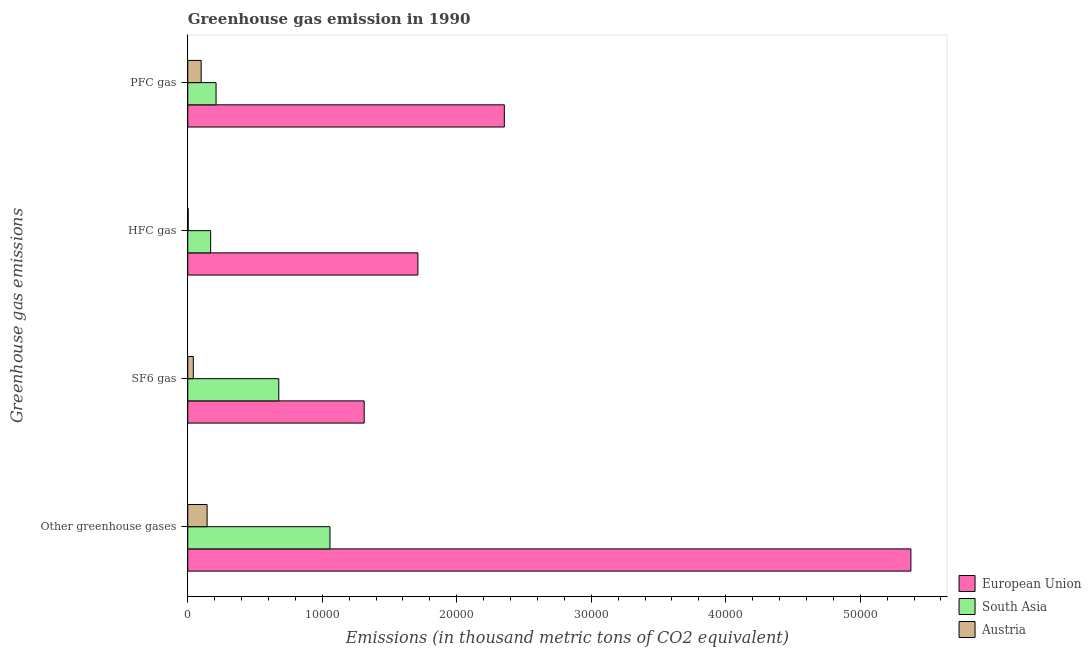Are the number of bars per tick equal to the number of legend labels?
Ensure brevity in your answer.  Yes. Are the number of bars on each tick of the Y-axis equal?
Provide a succinct answer. Yes. How many bars are there on the 2nd tick from the bottom?
Give a very brief answer. 3. What is the label of the 4th group of bars from the top?
Keep it short and to the point. Other greenhouse gases. What is the emission of pfc gas in European Union?
Give a very brief answer. 2.35e+04. Across all countries, what is the maximum emission of pfc gas?
Make the answer very short. 2.35e+04. Across all countries, what is the minimum emission of sf6 gas?
Your answer should be compact. 411.2. In which country was the emission of sf6 gas maximum?
Offer a terse response. European Union. In which country was the emission of sf6 gas minimum?
Offer a terse response. Austria. What is the total emission of pfc gas in the graph?
Ensure brevity in your answer.  2.66e+04. What is the difference between the emission of sf6 gas in Austria and that in South Asia?
Offer a very short reply. -6355.3. What is the difference between the emission of sf6 gas in South Asia and the emission of hfc gas in Austria?
Keep it short and to the point. 6735.6. What is the average emission of pfc gas per country?
Offer a very short reply. 8878.73. What is the difference between the emission of sf6 gas and emission of hfc gas in South Asia?
Your response must be concise. 5064.4. What is the ratio of the emission of hfc gas in Austria to that in South Asia?
Your answer should be very brief. 0.02. Is the emission of pfc gas in South Asia less than that in Austria?
Make the answer very short. No. What is the difference between the highest and the second highest emission of greenhouse gases?
Provide a succinct answer. 4.32e+04. What is the difference between the highest and the lowest emission of sf6 gas?
Ensure brevity in your answer.  1.27e+04. Is it the case that in every country, the sum of the emission of hfc gas and emission of pfc gas is greater than the sum of emission of sf6 gas and emission of greenhouse gases?
Provide a succinct answer. No. What does the 1st bar from the top in SF6 gas represents?
Your response must be concise. Austria. What does the 2nd bar from the bottom in HFC gas represents?
Your response must be concise. South Asia. Is it the case that in every country, the sum of the emission of greenhouse gases and emission of sf6 gas is greater than the emission of hfc gas?
Your response must be concise. Yes. Are all the bars in the graph horizontal?
Make the answer very short. Yes. What is the difference between two consecutive major ticks on the X-axis?
Provide a succinct answer. 10000. Does the graph contain any zero values?
Your answer should be very brief. No. Does the graph contain grids?
Give a very brief answer. No. How many legend labels are there?
Offer a very short reply. 3. What is the title of the graph?
Provide a succinct answer. Greenhouse gas emission in 1990. Does "Vanuatu" appear as one of the legend labels in the graph?
Keep it short and to the point. No. What is the label or title of the X-axis?
Your response must be concise. Emissions (in thousand metric tons of CO2 equivalent). What is the label or title of the Y-axis?
Your response must be concise. Greenhouse gas emissions. What is the Emissions (in thousand metric tons of CO2 equivalent) in European Union in Other greenhouse gases?
Your answer should be very brief. 5.38e+04. What is the Emissions (in thousand metric tons of CO2 equivalent) of South Asia in Other greenhouse gases?
Offer a terse response. 1.06e+04. What is the Emissions (in thousand metric tons of CO2 equivalent) in Austria in Other greenhouse gases?
Ensure brevity in your answer.  1437.8. What is the Emissions (in thousand metric tons of CO2 equivalent) in European Union in SF6 gas?
Your response must be concise. 1.31e+04. What is the Emissions (in thousand metric tons of CO2 equivalent) of South Asia in SF6 gas?
Your response must be concise. 6766.5. What is the Emissions (in thousand metric tons of CO2 equivalent) of Austria in SF6 gas?
Offer a very short reply. 411.2. What is the Emissions (in thousand metric tons of CO2 equivalent) in European Union in HFC gas?
Offer a very short reply. 1.71e+04. What is the Emissions (in thousand metric tons of CO2 equivalent) in South Asia in HFC gas?
Your response must be concise. 1702.1. What is the Emissions (in thousand metric tons of CO2 equivalent) in Austria in HFC gas?
Your response must be concise. 30.9. What is the Emissions (in thousand metric tons of CO2 equivalent) in European Union in PFC gas?
Make the answer very short. 2.35e+04. What is the Emissions (in thousand metric tons of CO2 equivalent) in South Asia in PFC gas?
Your response must be concise. 2104. What is the Emissions (in thousand metric tons of CO2 equivalent) of Austria in PFC gas?
Your answer should be compact. 995.7. Across all Greenhouse gas emissions, what is the maximum Emissions (in thousand metric tons of CO2 equivalent) in European Union?
Provide a short and direct response. 5.38e+04. Across all Greenhouse gas emissions, what is the maximum Emissions (in thousand metric tons of CO2 equivalent) of South Asia?
Provide a succinct answer. 1.06e+04. Across all Greenhouse gas emissions, what is the maximum Emissions (in thousand metric tons of CO2 equivalent) of Austria?
Offer a very short reply. 1437.8. Across all Greenhouse gas emissions, what is the minimum Emissions (in thousand metric tons of CO2 equivalent) in European Union?
Your answer should be very brief. 1.31e+04. Across all Greenhouse gas emissions, what is the minimum Emissions (in thousand metric tons of CO2 equivalent) of South Asia?
Give a very brief answer. 1702.1. Across all Greenhouse gas emissions, what is the minimum Emissions (in thousand metric tons of CO2 equivalent) in Austria?
Your answer should be very brief. 30.9. What is the total Emissions (in thousand metric tons of CO2 equivalent) in European Union in the graph?
Keep it short and to the point. 1.08e+05. What is the total Emissions (in thousand metric tons of CO2 equivalent) in South Asia in the graph?
Make the answer very short. 2.11e+04. What is the total Emissions (in thousand metric tons of CO2 equivalent) of Austria in the graph?
Offer a very short reply. 2875.6. What is the difference between the Emissions (in thousand metric tons of CO2 equivalent) of European Union in Other greenhouse gases and that in SF6 gas?
Keep it short and to the point. 4.06e+04. What is the difference between the Emissions (in thousand metric tons of CO2 equivalent) of South Asia in Other greenhouse gases and that in SF6 gas?
Offer a very short reply. 3806.1. What is the difference between the Emissions (in thousand metric tons of CO2 equivalent) of Austria in Other greenhouse gases and that in SF6 gas?
Ensure brevity in your answer.  1026.6. What is the difference between the Emissions (in thousand metric tons of CO2 equivalent) of European Union in Other greenhouse gases and that in HFC gas?
Keep it short and to the point. 3.67e+04. What is the difference between the Emissions (in thousand metric tons of CO2 equivalent) of South Asia in Other greenhouse gases and that in HFC gas?
Provide a short and direct response. 8870.5. What is the difference between the Emissions (in thousand metric tons of CO2 equivalent) of Austria in Other greenhouse gases and that in HFC gas?
Ensure brevity in your answer.  1406.9. What is the difference between the Emissions (in thousand metric tons of CO2 equivalent) of European Union in Other greenhouse gases and that in PFC gas?
Make the answer very short. 3.02e+04. What is the difference between the Emissions (in thousand metric tons of CO2 equivalent) in South Asia in Other greenhouse gases and that in PFC gas?
Give a very brief answer. 8468.6. What is the difference between the Emissions (in thousand metric tons of CO2 equivalent) of Austria in Other greenhouse gases and that in PFC gas?
Keep it short and to the point. 442.1. What is the difference between the Emissions (in thousand metric tons of CO2 equivalent) of European Union in SF6 gas and that in HFC gas?
Your response must be concise. -3993.7. What is the difference between the Emissions (in thousand metric tons of CO2 equivalent) of South Asia in SF6 gas and that in HFC gas?
Your answer should be compact. 5064.4. What is the difference between the Emissions (in thousand metric tons of CO2 equivalent) in Austria in SF6 gas and that in HFC gas?
Your response must be concise. 380.3. What is the difference between the Emissions (in thousand metric tons of CO2 equivalent) of European Union in SF6 gas and that in PFC gas?
Provide a short and direct response. -1.04e+04. What is the difference between the Emissions (in thousand metric tons of CO2 equivalent) of South Asia in SF6 gas and that in PFC gas?
Provide a short and direct response. 4662.5. What is the difference between the Emissions (in thousand metric tons of CO2 equivalent) in Austria in SF6 gas and that in PFC gas?
Ensure brevity in your answer.  -584.5. What is the difference between the Emissions (in thousand metric tons of CO2 equivalent) of European Union in HFC gas and that in PFC gas?
Your response must be concise. -6426.3. What is the difference between the Emissions (in thousand metric tons of CO2 equivalent) in South Asia in HFC gas and that in PFC gas?
Offer a very short reply. -401.9. What is the difference between the Emissions (in thousand metric tons of CO2 equivalent) in Austria in HFC gas and that in PFC gas?
Your answer should be compact. -964.8. What is the difference between the Emissions (in thousand metric tons of CO2 equivalent) in European Union in Other greenhouse gases and the Emissions (in thousand metric tons of CO2 equivalent) in South Asia in SF6 gas?
Keep it short and to the point. 4.70e+04. What is the difference between the Emissions (in thousand metric tons of CO2 equivalent) of European Union in Other greenhouse gases and the Emissions (in thousand metric tons of CO2 equivalent) of Austria in SF6 gas?
Ensure brevity in your answer.  5.34e+04. What is the difference between the Emissions (in thousand metric tons of CO2 equivalent) in South Asia in Other greenhouse gases and the Emissions (in thousand metric tons of CO2 equivalent) in Austria in SF6 gas?
Keep it short and to the point. 1.02e+04. What is the difference between the Emissions (in thousand metric tons of CO2 equivalent) of European Union in Other greenhouse gases and the Emissions (in thousand metric tons of CO2 equivalent) of South Asia in HFC gas?
Make the answer very short. 5.21e+04. What is the difference between the Emissions (in thousand metric tons of CO2 equivalent) of European Union in Other greenhouse gases and the Emissions (in thousand metric tons of CO2 equivalent) of Austria in HFC gas?
Your answer should be compact. 5.37e+04. What is the difference between the Emissions (in thousand metric tons of CO2 equivalent) of South Asia in Other greenhouse gases and the Emissions (in thousand metric tons of CO2 equivalent) of Austria in HFC gas?
Ensure brevity in your answer.  1.05e+04. What is the difference between the Emissions (in thousand metric tons of CO2 equivalent) of European Union in Other greenhouse gases and the Emissions (in thousand metric tons of CO2 equivalent) of South Asia in PFC gas?
Offer a terse response. 5.17e+04. What is the difference between the Emissions (in thousand metric tons of CO2 equivalent) in European Union in Other greenhouse gases and the Emissions (in thousand metric tons of CO2 equivalent) in Austria in PFC gas?
Give a very brief answer. 5.28e+04. What is the difference between the Emissions (in thousand metric tons of CO2 equivalent) in South Asia in Other greenhouse gases and the Emissions (in thousand metric tons of CO2 equivalent) in Austria in PFC gas?
Provide a succinct answer. 9576.9. What is the difference between the Emissions (in thousand metric tons of CO2 equivalent) in European Union in SF6 gas and the Emissions (in thousand metric tons of CO2 equivalent) in South Asia in HFC gas?
Give a very brief answer. 1.14e+04. What is the difference between the Emissions (in thousand metric tons of CO2 equivalent) in European Union in SF6 gas and the Emissions (in thousand metric tons of CO2 equivalent) in Austria in HFC gas?
Make the answer very short. 1.31e+04. What is the difference between the Emissions (in thousand metric tons of CO2 equivalent) in South Asia in SF6 gas and the Emissions (in thousand metric tons of CO2 equivalent) in Austria in HFC gas?
Provide a short and direct response. 6735.6. What is the difference between the Emissions (in thousand metric tons of CO2 equivalent) in European Union in SF6 gas and the Emissions (in thousand metric tons of CO2 equivalent) in South Asia in PFC gas?
Your response must be concise. 1.10e+04. What is the difference between the Emissions (in thousand metric tons of CO2 equivalent) of European Union in SF6 gas and the Emissions (in thousand metric tons of CO2 equivalent) of Austria in PFC gas?
Provide a short and direct response. 1.21e+04. What is the difference between the Emissions (in thousand metric tons of CO2 equivalent) in South Asia in SF6 gas and the Emissions (in thousand metric tons of CO2 equivalent) in Austria in PFC gas?
Provide a short and direct response. 5770.8. What is the difference between the Emissions (in thousand metric tons of CO2 equivalent) of European Union in HFC gas and the Emissions (in thousand metric tons of CO2 equivalent) of South Asia in PFC gas?
Offer a very short reply. 1.50e+04. What is the difference between the Emissions (in thousand metric tons of CO2 equivalent) of European Union in HFC gas and the Emissions (in thousand metric tons of CO2 equivalent) of Austria in PFC gas?
Make the answer very short. 1.61e+04. What is the difference between the Emissions (in thousand metric tons of CO2 equivalent) of South Asia in HFC gas and the Emissions (in thousand metric tons of CO2 equivalent) of Austria in PFC gas?
Ensure brevity in your answer.  706.4. What is the average Emissions (in thousand metric tons of CO2 equivalent) of European Union per Greenhouse gas emissions?
Give a very brief answer. 2.69e+04. What is the average Emissions (in thousand metric tons of CO2 equivalent) of South Asia per Greenhouse gas emissions?
Provide a short and direct response. 5286.3. What is the average Emissions (in thousand metric tons of CO2 equivalent) in Austria per Greenhouse gas emissions?
Offer a terse response. 718.9. What is the difference between the Emissions (in thousand metric tons of CO2 equivalent) of European Union and Emissions (in thousand metric tons of CO2 equivalent) of South Asia in Other greenhouse gases?
Provide a succinct answer. 4.32e+04. What is the difference between the Emissions (in thousand metric tons of CO2 equivalent) in European Union and Emissions (in thousand metric tons of CO2 equivalent) in Austria in Other greenhouse gases?
Make the answer very short. 5.23e+04. What is the difference between the Emissions (in thousand metric tons of CO2 equivalent) in South Asia and Emissions (in thousand metric tons of CO2 equivalent) in Austria in Other greenhouse gases?
Provide a succinct answer. 9134.8. What is the difference between the Emissions (in thousand metric tons of CO2 equivalent) in European Union and Emissions (in thousand metric tons of CO2 equivalent) in South Asia in SF6 gas?
Make the answer very short. 6350. What is the difference between the Emissions (in thousand metric tons of CO2 equivalent) of European Union and Emissions (in thousand metric tons of CO2 equivalent) of Austria in SF6 gas?
Your response must be concise. 1.27e+04. What is the difference between the Emissions (in thousand metric tons of CO2 equivalent) in South Asia and Emissions (in thousand metric tons of CO2 equivalent) in Austria in SF6 gas?
Provide a short and direct response. 6355.3. What is the difference between the Emissions (in thousand metric tons of CO2 equivalent) in European Union and Emissions (in thousand metric tons of CO2 equivalent) in South Asia in HFC gas?
Provide a succinct answer. 1.54e+04. What is the difference between the Emissions (in thousand metric tons of CO2 equivalent) in European Union and Emissions (in thousand metric tons of CO2 equivalent) in Austria in HFC gas?
Keep it short and to the point. 1.71e+04. What is the difference between the Emissions (in thousand metric tons of CO2 equivalent) of South Asia and Emissions (in thousand metric tons of CO2 equivalent) of Austria in HFC gas?
Your response must be concise. 1671.2. What is the difference between the Emissions (in thousand metric tons of CO2 equivalent) of European Union and Emissions (in thousand metric tons of CO2 equivalent) of South Asia in PFC gas?
Ensure brevity in your answer.  2.14e+04. What is the difference between the Emissions (in thousand metric tons of CO2 equivalent) of European Union and Emissions (in thousand metric tons of CO2 equivalent) of Austria in PFC gas?
Keep it short and to the point. 2.25e+04. What is the difference between the Emissions (in thousand metric tons of CO2 equivalent) of South Asia and Emissions (in thousand metric tons of CO2 equivalent) of Austria in PFC gas?
Keep it short and to the point. 1108.3. What is the ratio of the Emissions (in thousand metric tons of CO2 equivalent) of European Union in Other greenhouse gases to that in SF6 gas?
Provide a short and direct response. 4.1. What is the ratio of the Emissions (in thousand metric tons of CO2 equivalent) in South Asia in Other greenhouse gases to that in SF6 gas?
Your answer should be very brief. 1.56. What is the ratio of the Emissions (in thousand metric tons of CO2 equivalent) of Austria in Other greenhouse gases to that in SF6 gas?
Provide a short and direct response. 3.5. What is the ratio of the Emissions (in thousand metric tons of CO2 equivalent) of European Union in Other greenhouse gases to that in HFC gas?
Your answer should be very brief. 3.14. What is the ratio of the Emissions (in thousand metric tons of CO2 equivalent) in South Asia in Other greenhouse gases to that in HFC gas?
Your response must be concise. 6.21. What is the ratio of the Emissions (in thousand metric tons of CO2 equivalent) of Austria in Other greenhouse gases to that in HFC gas?
Provide a succinct answer. 46.53. What is the ratio of the Emissions (in thousand metric tons of CO2 equivalent) of European Union in Other greenhouse gases to that in PFC gas?
Provide a succinct answer. 2.28. What is the ratio of the Emissions (in thousand metric tons of CO2 equivalent) of South Asia in Other greenhouse gases to that in PFC gas?
Ensure brevity in your answer.  5.03. What is the ratio of the Emissions (in thousand metric tons of CO2 equivalent) in Austria in Other greenhouse gases to that in PFC gas?
Provide a succinct answer. 1.44. What is the ratio of the Emissions (in thousand metric tons of CO2 equivalent) of European Union in SF6 gas to that in HFC gas?
Your answer should be compact. 0.77. What is the ratio of the Emissions (in thousand metric tons of CO2 equivalent) of South Asia in SF6 gas to that in HFC gas?
Offer a terse response. 3.98. What is the ratio of the Emissions (in thousand metric tons of CO2 equivalent) of Austria in SF6 gas to that in HFC gas?
Provide a succinct answer. 13.31. What is the ratio of the Emissions (in thousand metric tons of CO2 equivalent) in European Union in SF6 gas to that in PFC gas?
Your answer should be compact. 0.56. What is the ratio of the Emissions (in thousand metric tons of CO2 equivalent) of South Asia in SF6 gas to that in PFC gas?
Make the answer very short. 3.22. What is the ratio of the Emissions (in thousand metric tons of CO2 equivalent) of Austria in SF6 gas to that in PFC gas?
Make the answer very short. 0.41. What is the ratio of the Emissions (in thousand metric tons of CO2 equivalent) of European Union in HFC gas to that in PFC gas?
Offer a terse response. 0.73. What is the ratio of the Emissions (in thousand metric tons of CO2 equivalent) of South Asia in HFC gas to that in PFC gas?
Your answer should be very brief. 0.81. What is the ratio of the Emissions (in thousand metric tons of CO2 equivalent) in Austria in HFC gas to that in PFC gas?
Provide a succinct answer. 0.03. What is the difference between the highest and the second highest Emissions (in thousand metric tons of CO2 equivalent) in European Union?
Offer a terse response. 3.02e+04. What is the difference between the highest and the second highest Emissions (in thousand metric tons of CO2 equivalent) in South Asia?
Keep it short and to the point. 3806.1. What is the difference between the highest and the second highest Emissions (in thousand metric tons of CO2 equivalent) of Austria?
Your answer should be compact. 442.1. What is the difference between the highest and the lowest Emissions (in thousand metric tons of CO2 equivalent) in European Union?
Offer a terse response. 4.06e+04. What is the difference between the highest and the lowest Emissions (in thousand metric tons of CO2 equivalent) in South Asia?
Offer a very short reply. 8870.5. What is the difference between the highest and the lowest Emissions (in thousand metric tons of CO2 equivalent) in Austria?
Give a very brief answer. 1406.9. 